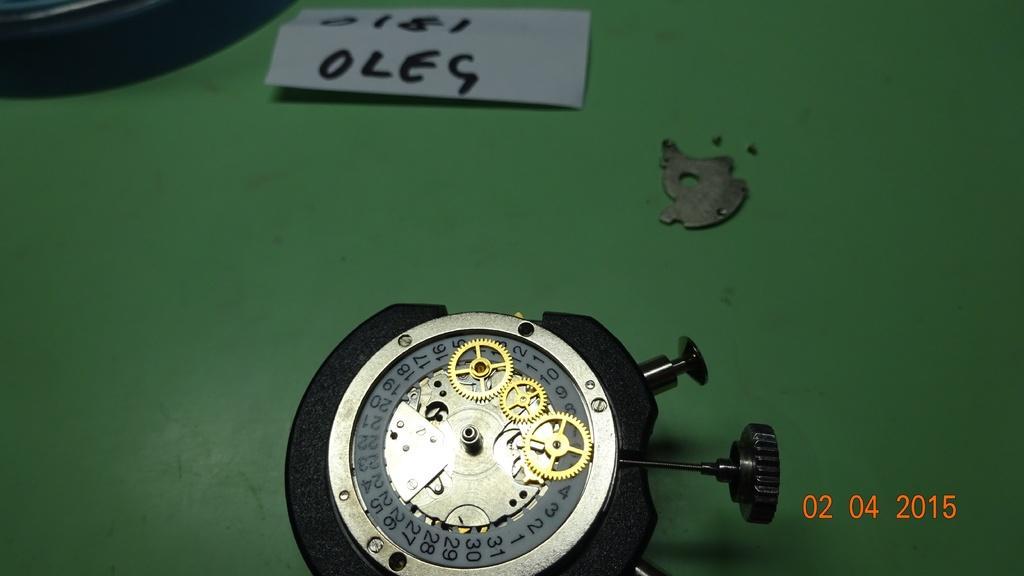Can you describe this image briefly? In this image I can see the black color object, paper and few more objects on the green color surface. 